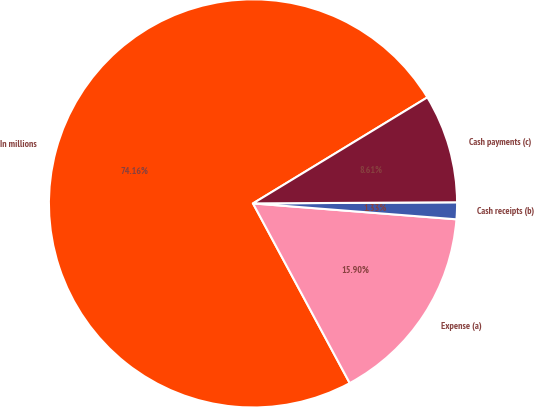Convert chart. <chart><loc_0><loc_0><loc_500><loc_500><pie_chart><fcel>In millions<fcel>Expense (a)<fcel>Cash receipts (b)<fcel>Cash payments (c)<nl><fcel>74.17%<fcel>15.9%<fcel>1.33%<fcel>8.61%<nl></chart> 